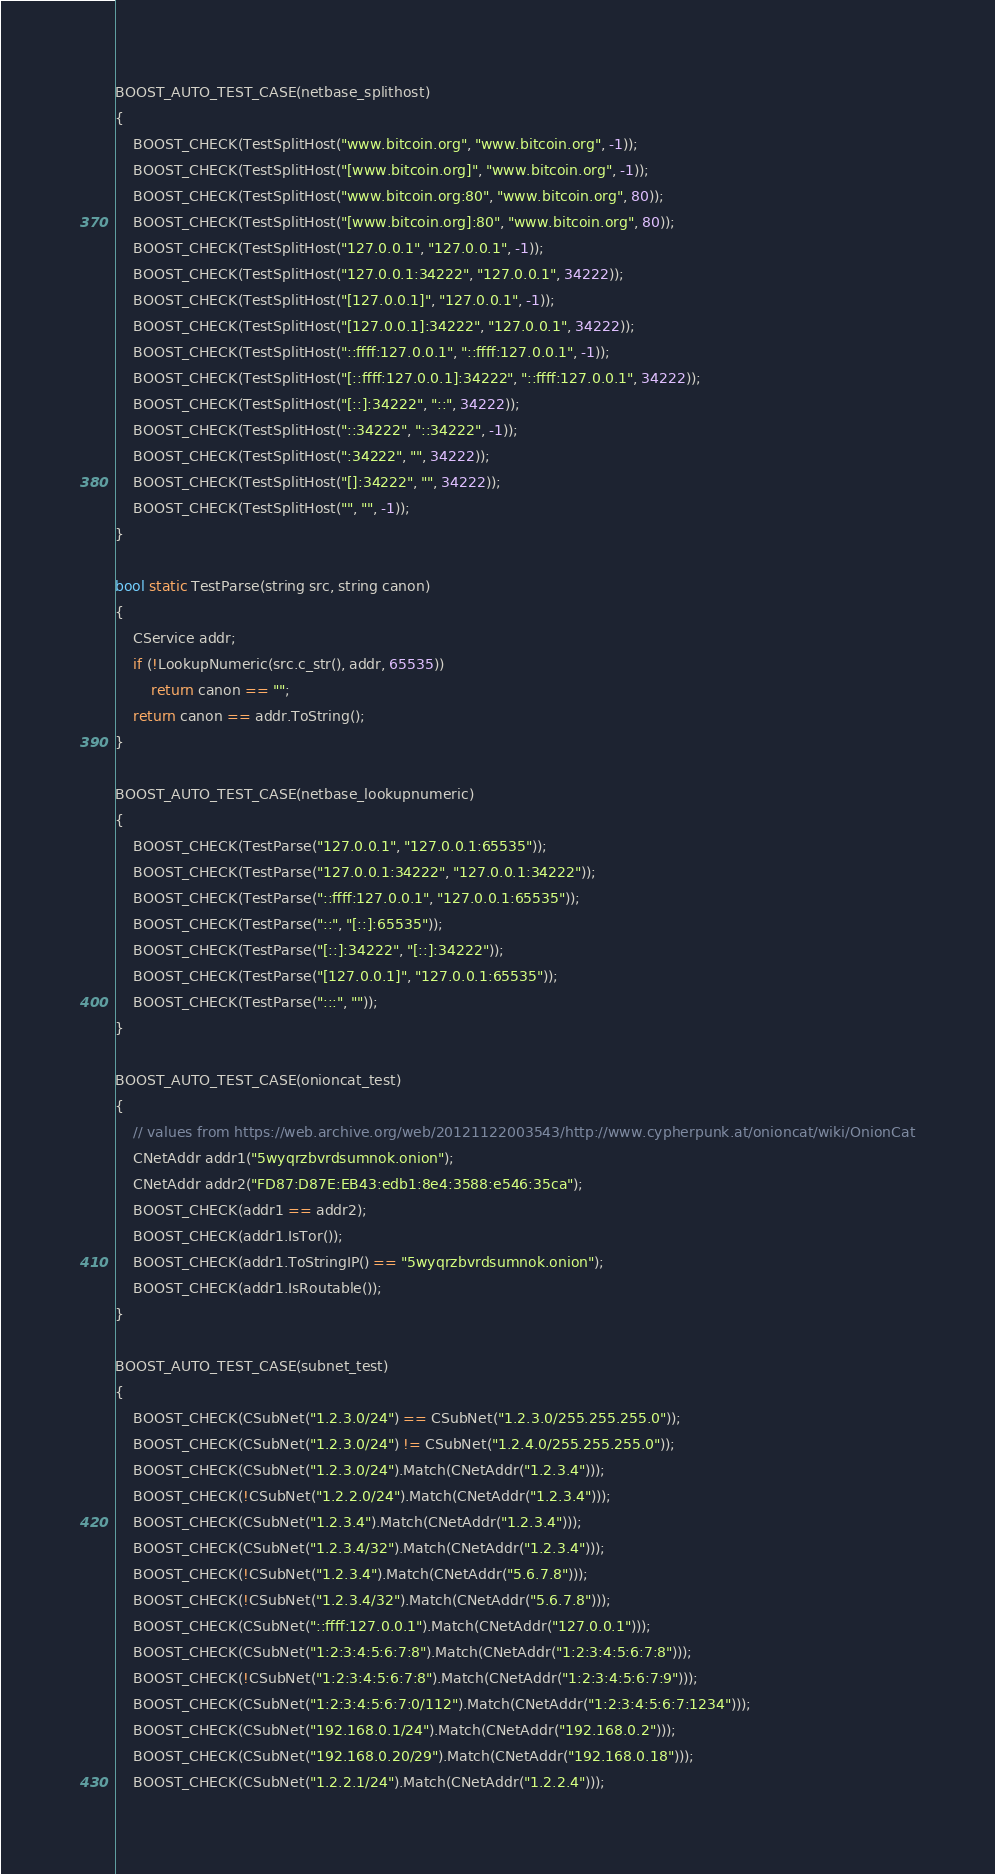Convert code to text. <code><loc_0><loc_0><loc_500><loc_500><_C++_>
BOOST_AUTO_TEST_CASE(netbase_splithost)
{
    BOOST_CHECK(TestSplitHost("www.bitcoin.org", "www.bitcoin.org", -1));
    BOOST_CHECK(TestSplitHost("[www.bitcoin.org]", "www.bitcoin.org", -1));
    BOOST_CHECK(TestSplitHost("www.bitcoin.org:80", "www.bitcoin.org", 80));
    BOOST_CHECK(TestSplitHost("[www.bitcoin.org]:80", "www.bitcoin.org", 80));
    BOOST_CHECK(TestSplitHost("127.0.0.1", "127.0.0.1", -1));
    BOOST_CHECK(TestSplitHost("127.0.0.1:34222", "127.0.0.1", 34222));
    BOOST_CHECK(TestSplitHost("[127.0.0.1]", "127.0.0.1", -1));
    BOOST_CHECK(TestSplitHost("[127.0.0.1]:34222", "127.0.0.1", 34222));
    BOOST_CHECK(TestSplitHost("::ffff:127.0.0.1", "::ffff:127.0.0.1", -1));
    BOOST_CHECK(TestSplitHost("[::ffff:127.0.0.1]:34222", "::ffff:127.0.0.1", 34222));
    BOOST_CHECK(TestSplitHost("[::]:34222", "::", 34222));
    BOOST_CHECK(TestSplitHost("::34222", "::34222", -1));
    BOOST_CHECK(TestSplitHost(":34222", "", 34222));
    BOOST_CHECK(TestSplitHost("[]:34222", "", 34222));
    BOOST_CHECK(TestSplitHost("", "", -1));
}

bool static TestParse(string src, string canon)
{
    CService addr;
    if (!LookupNumeric(src.c_str(), addr, 65535))
        return canon == "";
    return canon == addr.ToString();
}

BOOST_AUTO_TEST_CASE(netbase_lookupnumeric)
{
    BOOST_CHECK(TestParse("127.0.0.1", "127.0.0.1:65535"));
    BOOST_CHECK(TestParse("127.0.0.1:34222", "127.0.0.1:34222"));
    BOOST_CHECK(TestParse("::ffff:127.0.0.1", "127.0.0.1:65535"));
    BOOST_CHECK(TestParse("::", "[::]:65535"));
    BOOST_CHECK(TestParse("[::]:34222", "[::]:34222"));
    BOOST_CHECK(TestParse("[127.0.0.1]", "127.0.0.1:65535"));
    BOOST_CHECK(TestParse(":::", ""));
}

BOOST_AUTO_TEST_CASE(onioncat_test)
{
    // values from https://web.archive.org/web/20121122003543/http://www.cypherpunk.at/onioncat/wiki/OnionCat
    CNetAddr addr1("5wyqrzbvrdsumnok.onion");
    CNetAddr addr2("FD87:D87E:EB43:edb1:8e4:3588:e546:35ca");
    BOOST_CHECK(addr1 == addr2);
    BOOST_CHECK(addr1.IsTor());
    BOOST_CHECK(addr1.ToStringIP() == "5wyqrzbvrdsumnok.onion");
    BOOST_CHECK(addr1.IsRoutable());
}

BOOST_AUTO_TEST_CASE(subnet_test)
{
    BOOST_CHECK(CSubNet("1.2.3.0/24") == CSubNet("1.2.3.0/255.255.255.0"));
    BOOST_CHECK(CSubNet("1.2.3.0/24") != CSubNet("1.2.4.0/255.255.255.0"));
    BOOST_CHECK(CSubNet("1.2.3.0/24").Match(CNetAddr("1.2.3.4")));
    BOOST_CHECK(!CSubNet("1.2.2.0/24").Match(CNetAddr("1.2.3.4")));
    BOOST_CHECK(CSubNet("1.2.3.4").Match(CNetAddr("1.2.3.4")));
    BOOST_CHECK(CSubNet("1.2.3.4/32").Match(CNetAddr("1.2.3.4")));
    BOOST_CHECK(!CSubNet("1.2.3.4").Match(CNetAddr("5.6.7.8")));
    BOOST_CHECK(!CSubNet("1.2.3.4/32").Match(CNetAddr("5.6.7.8")));
    BOOST_CHECK(CSubNet("::ffff:127.0.0.1").Match(CNetAddr("127.0.0.1")));
    BOOST_CHECK(CSubNet("1:2:3:4:5:6:7:8").Match(CNetAddr("1:2:3:4:5:6:7:8")));
    BOOST_CHECK(!CSubNet("1:2:3:4:5:6:7:8").Match(CNetAddr("1:2:3:4:5:6:7:9")));
    BOOST_CHECK(CSubNet("1:2:3:4:5:6:7:0/112").Match(CNetAddr("1:2:3:4:5:6:7:1234")));
    BOOST_CHECK(CSubNet("192.168.0.1/24").Match(CNetAddr("192.168.0.2")));
    BOOST_CHECK(CSubNet("192.168.0.20/29").Match(CNetAddr("192.168.0.18")));
    BOOST_CHECK(CSubNet("1.2.2.1/24").Match(CNetAddr("1.2.2.4")));</code> 